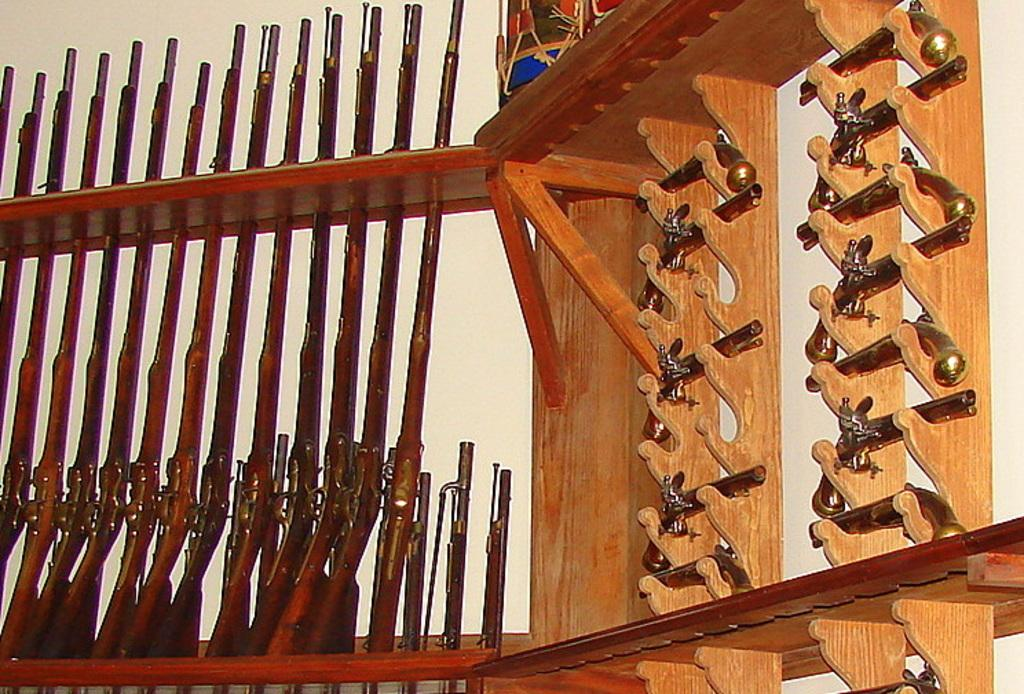What type of objects are in the image? There are pistols and weapons in the image. Where are the pistols and weapons located? The pistols and weapons are on wooden shelves. What type of bird can be seen flying through the image? There is no bird present in the image. What type of pipe is visible in the image? There is no pipe present in the image. 